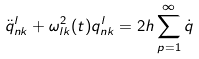Convert formula to latex. <formula><loc_0><loc_0><loc_500><loc_500>\ddot { q } _ { n k } ^ { l } + \omega _ { l k } ^ { 2 } ( t ) q _ { n k } ^ { l } = 2 h \sum _ { p = 1 } ^ { \infty } \dot { q }</formula> 